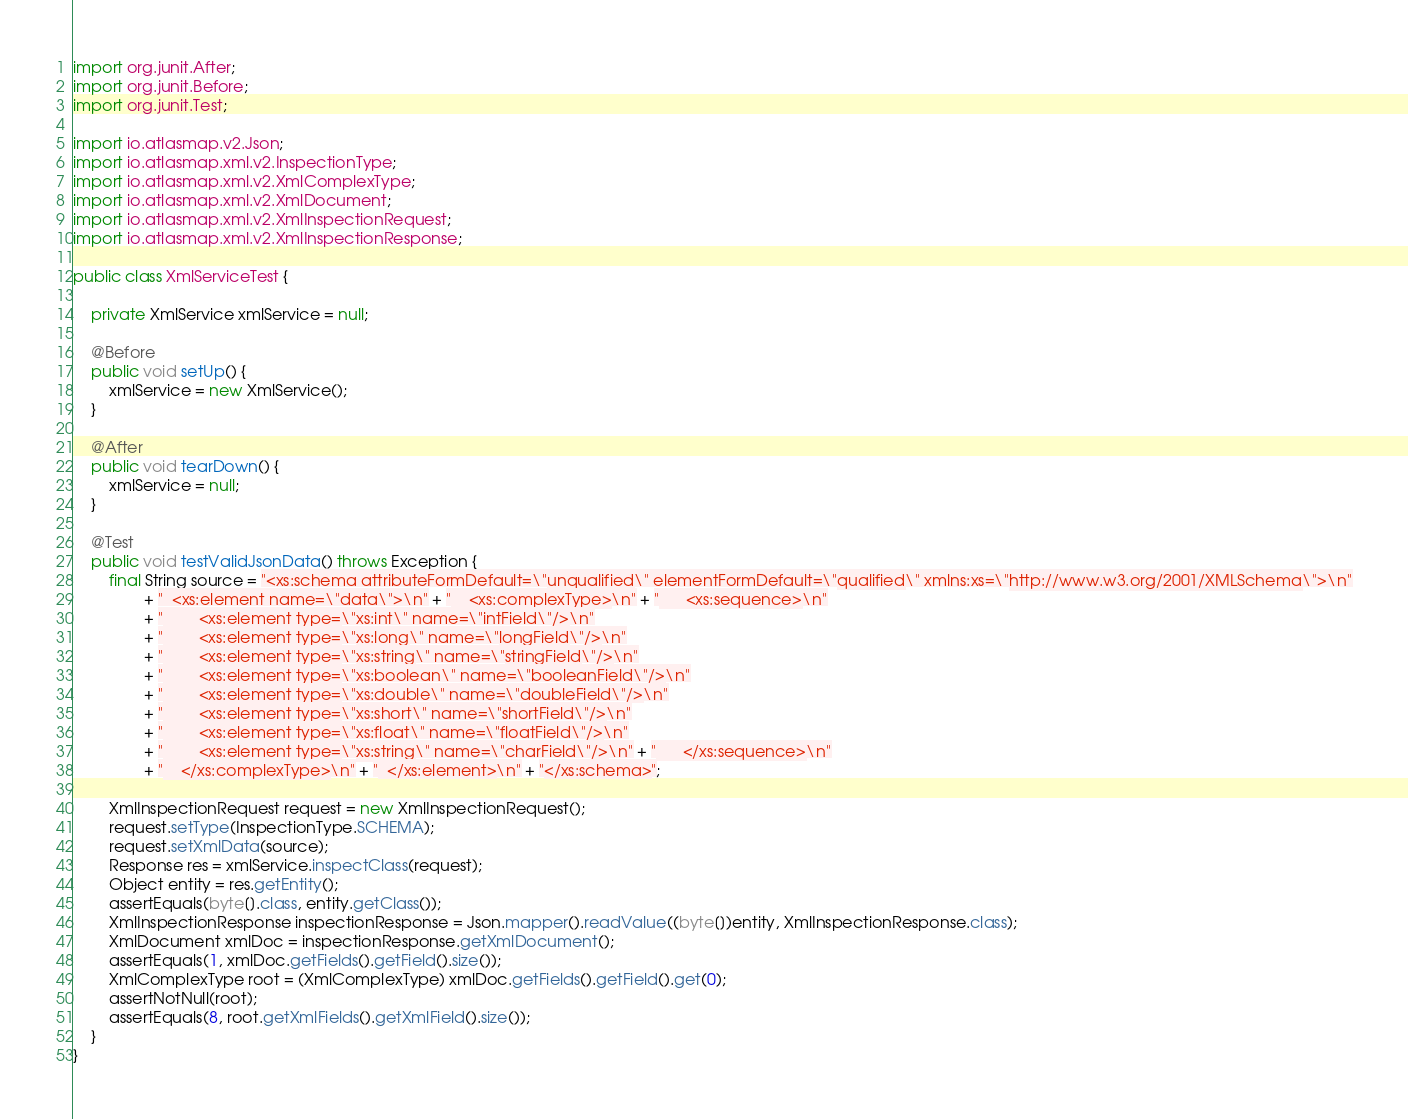Convert code to text. <code><loc_0><loc_0><loc_500><loc_500><_Java_>
import org.junit.After;
import org.junit.Before;
import org.junit.Test;

import io.atlasmap.v2.Json;
import io.atlasmap.xml.v2.InspectionType;
import io.atlasmap.xml.v2.XmlComplexType;
import io.atlasmap.xml.v2.XmlDocument;
import io.atlasmap.xml.v2.XmlInspectionRequest;
import io.atlasmap.xml.v2.XmlInspectionResponse;

public class XmlServiceTest {

    private XmlService xmlService = null;

    @Before
    public void setUp() {
        xmlService = new XmlService();
    }

    @After
    public void tearDown() {
        xmlService = null;
    }

    @Test
    public void testValidJsonData() throws Exception {
        final String source = "<xs:schema attributeFormDefault=\"unqualified\" elementFormDefault=\"qualified\" xmlns:xs=\"http://www.w3.org/2001/XMLSchema\">\n"
                + "  <xs:element name=\"data\">\n" + "    <xs:complexType>\n" + "      <xs:sequence>\n"
                + "        <xs:element type=\"xs:int\" name=\"intField\"/>\n"
                + "        <xs:element type=\"xs:long\" name=\"longField\"/>\n"
                + "        <xs:element type=\"xs:string\" name=\"stringField\"/>\n"
                + "        <xs:element type=\"xs:boolean\" name=\"booleanField\"/>\n"
                + "        <xs:element type=\"xs:double\" name=\"doubleField\"/>\n"
                + "        <xs:element type=\"xs:short\" name=\"shortField\"/>\n"
                + "        <xs:element type=\"xs:float\" name=\"floatField\"/>\n"
                + "        <xs:element type=\"xs:string\" name=\"charField\"/>\n" + "      </xs:sequence>\n"
                + "    </xs:complexType>\n" + "  </xs:element>\n" + "</xs:schema>";

        XmlInspectionRequest request = new XmlInspectionRequest();
        request.setType(InspectionType.SCHEMA);
        request.setXmlData(source);
        Response res = xmlService.inspectClass(request);
        Object entity = res.getEntity();
        assertEquals(byte[].class, entity.getClass());
        XmlInspectionResponse inspectionResponse = Json.mapper().readValue((byte[])entity, XmlInspectionResponse.class);
        XmlDocument xmlDoc = inspectionResponse.getXmlDocument();
        assertEquals(1, xmlDoc.getFields().getField().size());
        XmlComplexType root = (XmlComplexType) xmlDoc.getFields().getField().get(0);
        assertNotNull(root);
        assertEquals(8, root.getXmlFields().getXmlField().size());
    }
}
</code> 